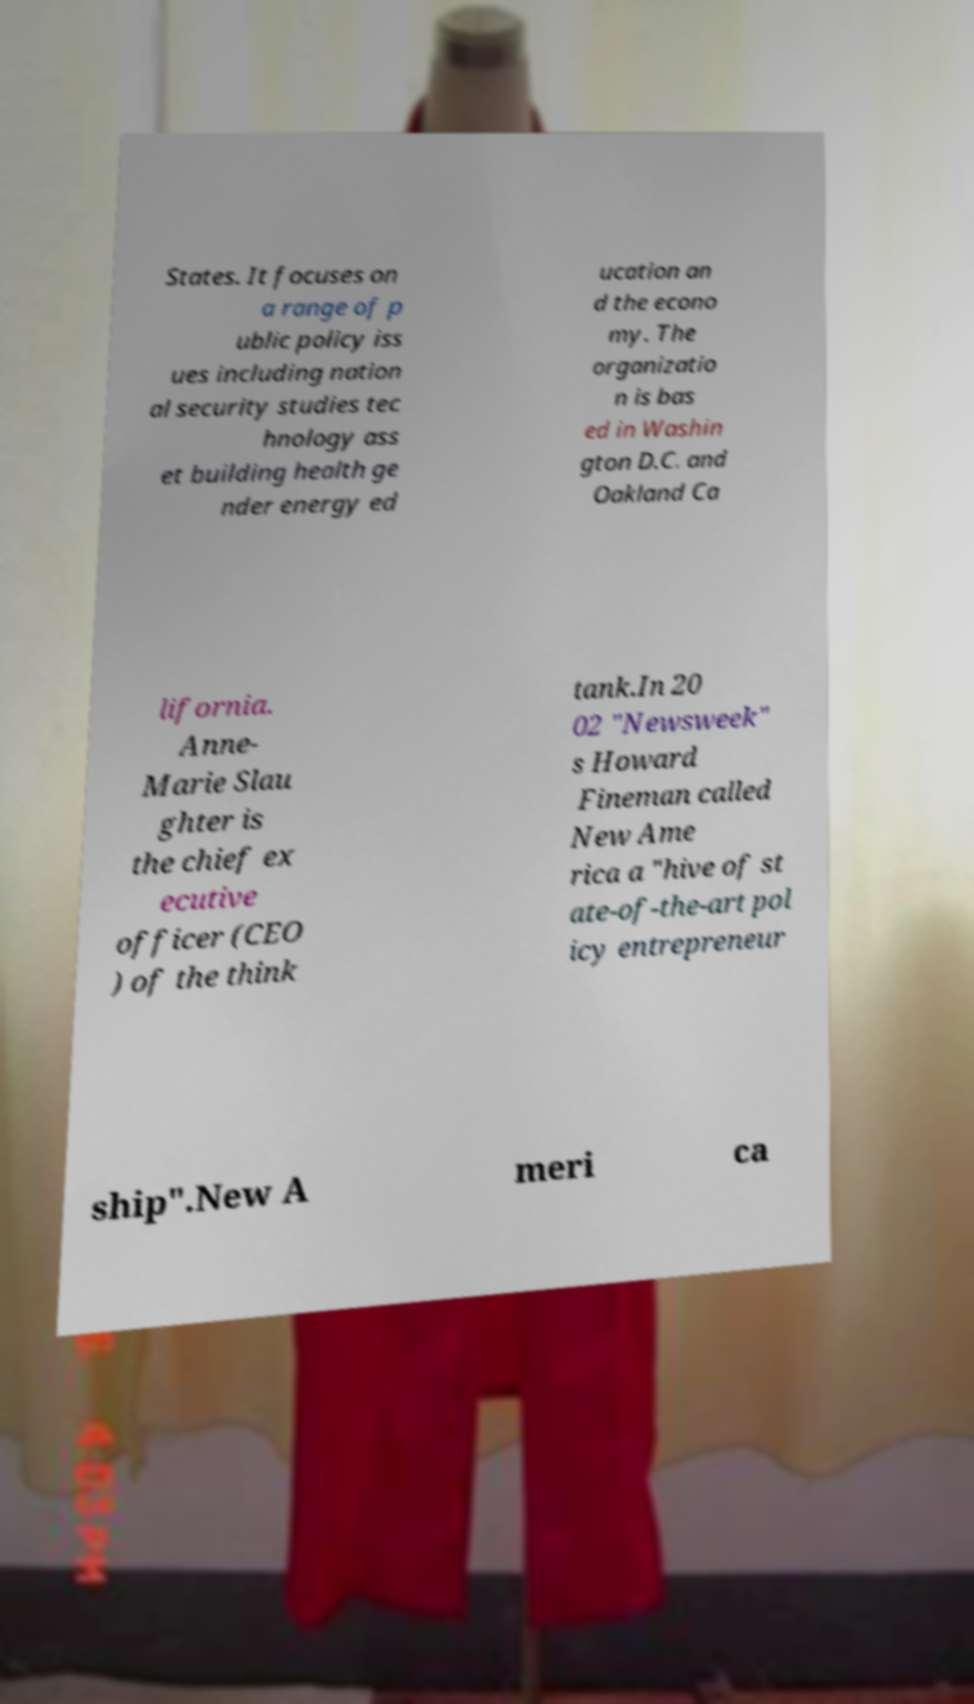Can you accurately transcribe the text from the provided image for me? States. It focuses on a range of p ublic policy iss ues including nation al security studies tec hnology ass et building health ge nder energy ed ucation an d the econo my. The organizatio n is bas ed in Washin gton D.C. and Oakland Ca lifornia. Anne- Marie Slau ghter is the chief ex ecutive officer (CEO ) of the think tank.In 20 02 "Newsweek" s Howard Fineman called New Ame rica a "hive of st ate-of-the-art pol icy entrepreneur ship".New A meri ca 